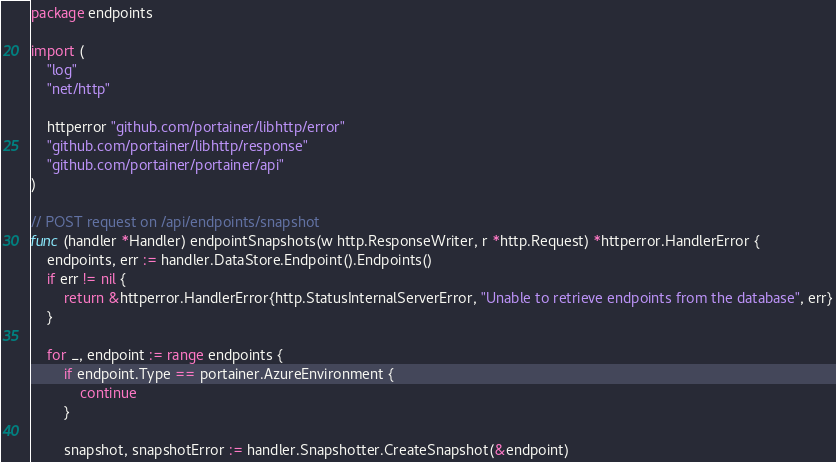Convert code to text. <code><loc_0><loc_0><loc_500><loc_500><_Go_>package endpoints

import (
	"log"
	"net/http"

	httperror "github.com/portainer/libhttp/error"
	"github.com/portainer/libhttp/response"
	"github.com/portainer/portainer/api"
)

// POST request on /api/endpoints/snapshot
func (handler *Handler) endpointSnapshots(w http.ResponseWriter, r *http.Request) *httperror.HandlerError {
	endpoints, err := handler.DataStore.Endpoint().Endpoints()
	if err != nil {
		return &httperror.HandlerError{http.StatusInternalServerError, "Unable to retrieve endpoints from the database", err}
	}

	for _, endpoint := range endpoints {
		if endpoint.Type == portainer.AzureEnvironment {
			continue
		}

		snapshot, snapshotError := handler.Snapshotter.CreateSnapshot(&endpoint)
</code> 